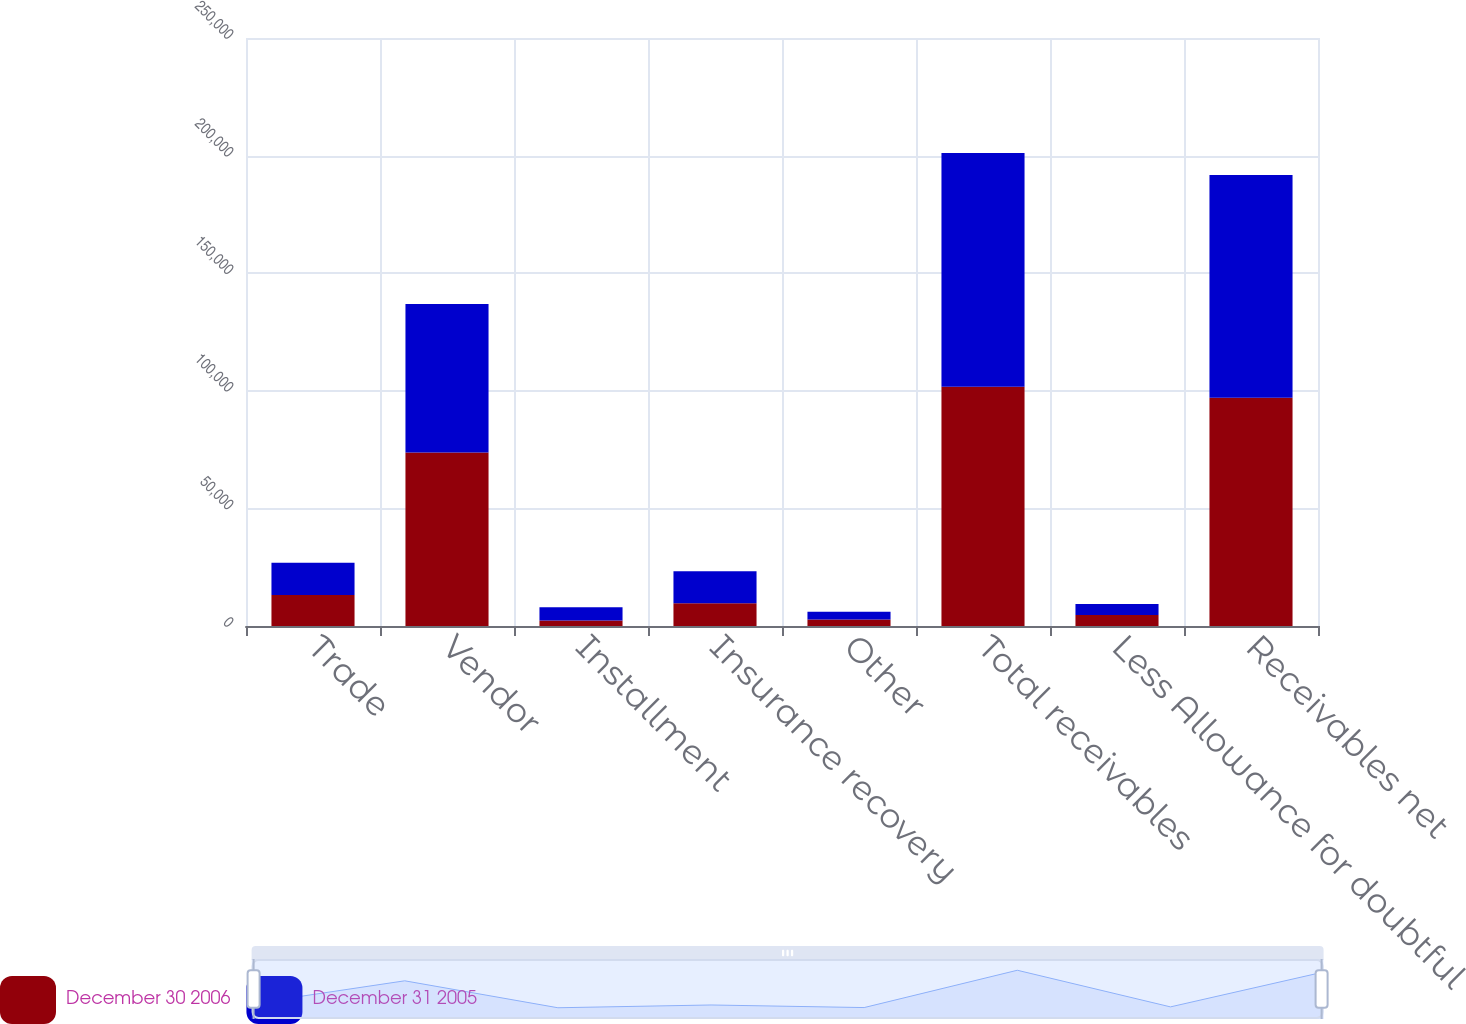<chart> <loc_0><loc_0><loc_500><loc_500><stacked_bar_chart><ecel><fcel>Trade<fcel>Vendor<fcel>Installment<fcel>Insurance recovery<fcel>Other<fcel>Total receivables<fcel>Less Allowance for doubtful<fcel>Receivables net<nl><fcel>December 30 2006<fcel>13149<fcel>73724<fcel>2336<fcel>9676<fcel>2801<fcel>101686<fcel>4640<fcel>97046<nl><fcel>December 31 2005<fcel>13733<fcel>63161<fcel>5622<fcel>13629<fcel>3230<fcel>99375<fcel>4686<fcel>94689<nl></chart> 